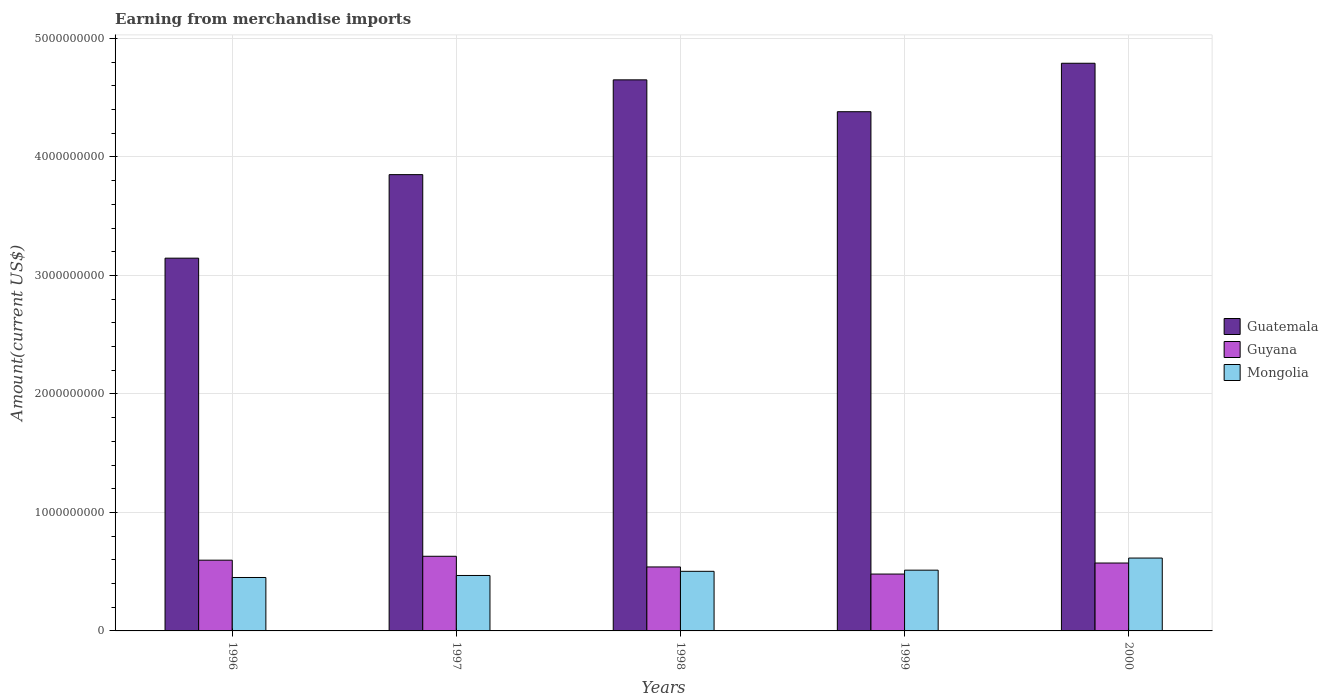How many groups of bars are there?
Give a very brief answer. 5. Are the number of bars per tick equal to the number of legend labels?
Give a very brief answer. Yes. Are the number of bars on each tick of the X-axis equal?
Offer a terse response. Yes. What is the amount earned from merchandise imports in Guyana in 1997?
Give a very brief answer. 6.30e+08. Across all years, what is the maximum amount earned from merchandise imports in Guyana?
Give a very brief answer. 6.30e+08. Across all years, what is the minimum amount earned from merchandise imports in Mongolia?
Give a very brief answer. 4.51e+08. In which year was the amount earned from merchandise imports in Guatemala maximum?
Offer a very short reply. 2000. What is the total amount earned from merchandise imports in Mongolia in the graph?
Ensure brevity in your answer.  2.55e+09. What is the difference between the amount earned from merchandise imports in Mongolia in 1996 and that in 1999?
Your answer should be compact. -6.18e+07. What is the difference between the amount earned from merchandise imports in Guyana in 2000 and the amount earned from merchandise imports in Mongolia in 1998?
Your answer should be very brief. 7.00e+07. What is the average amount earned from merchandise imports in Mongolia per year?
Your answer should be compact. 5.10e+08. In the year 1998, what is the difference between the amount earned from merchandise imports in Mongolia and amount earned from merchandise imports in Guyana?
Offer a very short reply. -3.70e+07. What is the ratio of the amount earned from merchandise imports in Guyana in 1996 to that in 1999?
Your answer should be compact. 1.24. Is the difference between the amount earned from merchandise imports in Mongolia in 1998 and 2000 greater than the difference between the amount earned from merchandise imports in Guyana in 1998 and 2000?
Offer a terse response. No. What is the difference between the highest and the second highest amount earned from merchandise imports in Guatemala?
Offer a very short reply. 1.40e+08. What is the difference between the highest and the lowest amount earned from merchandise imports in Guatemala?
Your answer should be compact. 1.64e+09. Is the sum of the amount earned from merchandise imports in Guatemala in 1996 and 1999 greater than the maximum amount earned from merchandise imports in Guyana across all years?
Make the answer very short. Yes. What does the 1st bar from the left in 2000 represents?
Make the answer very short. Guatemala. What does the 1st bar from the right in 1998 represents?
Make the answer very short. Mongolia. Are all the bars in the graph horizontal?
Provide a succinct answer. No. What is the difference between two consecutive major ticks on the Y-axis?
Your answer should be compact. 1.00e+09. Does the graph contain any zero values?
Offer a terse response. No. Does the graph contain grids?
Make the answer very short. Yes. How are the legend labels stacked?
Offer a very short reply. Vertical. What is the title of the graph?
Give a very brief answer. Earning from merchandise imports. Does "New Zealand" appear as one of the legend labels in the graph?
Give a very brief answer. No. What is the label or title of the Y-axis?
Make the answer very short. Amount(current US$). What is the Amount(current US$) in Guatemala in 1996?
Your response must be concise. 3.15e+09. What is the Amount(current US$) of Guyana in 1996?
Your answer should be very brief. 5.97e+08. What is the Amount(current US$) of Mongolia in 1996?
Give a very brief answer. 4.51e+08. What is the Amount(current US$) in Guatemala in 1997?
Keep it short and to the point. 3.85e+09. What is the Amount(current US$) in Guyana in 1997?
Provide a short and direct response. 6.30e+08. What is the Amount(current US$) of Mongolia in 1997?
Your answer should be compact. 4.68e+08. What is the Amount(current US$) of Guatemala in 1998?
Make the answer very short. 4.65e+09. What is the Amount(current US$) in Guyana in 1998?
Make the answer very short. 5.40e+08. What is the Amount(current US$) in Mongolia in 1998?
Your answer should be very brief. 5.03e+08. What is the Amount(current US$) in Guatemala in 1999?
Offer a terse response. 4.38e+09. What is the Amount(current US$) in Guyana in 1999?
Give a very brief answer. 4.80e+08. What is the Amount(current US$) of Mongolia in 1999?
Your response must be concise. 5.13e+08. What is the Amount(current US$) in Guatemala in 2000?
Your answer should be compact. 4.79e+09. What is the Amount(current US$) in Guyana in 2000?
Keep it short and to the point. 5.73e+08. What is the Amount(current US$) of Mongolia in 2000?
Keep it short and to the point. 6.15e+08. Across all years, what is the maximum Amount(current US$) of Guatemala?
Offer a terse response. 4.79e+09. Across all years, what is the maximum Amount(current US$) of Guyana?
Your answer should be compact. 6.30e+08. Across all years, what is the maximum Amount(current US$) in Mongolia?
Ensure brevity in your answer.  6.15e+08. Across all years, what is the minimum Amount(current US$) in Guatemala?
Provide a short and direct response. 3.15e+09. Across all years, what is the minimum Amount(current US$) of Guyana?
Ensure brevity in your answer.  4.80e+08. Across all years, what is the minimum Amount(current US$) in Mongolia?
Your response must be concise. 4.51e+08. What is the total Amount(current US$) of Guatemala in the graph?
Make the answer very short. 2.08e+1. What is the total Amount(current US$) in Guyana in the graph?
Give a very brief answer. 2.82e+09. What is the total Amount(current US$) in Mongolia in the graph?
Offer a terse response. 2.55e+09. What is the difference between the Amount(current US$) in Guatemala in 1996 and that in 1997?
Ensure brevity in your answer.  -7.05e+08. What is the difference between the Amount(current US$) in Guyana in 1996 and that in 1997?
Offer a very short reply. -3.30e+07. What is the difference between the Amount(current US$) of Mongolia in 1996 and that in 1997?
Your response must be concise. -1.70e+07. What is the difference between the Amount(current US$) of Guatemala in 1996 and that in 1998?
Provide a short and direct response. -1.50e+09. What is the difference between the Amount(current US$) in Guyana in 1996 and that in 1998?
Make the answer very short. 5.70e+07. What is the difference between the Amount(current US$) in Mongolia in 1996 and that in 1998?
Offer a terse response. -5.20e+07. What is the difference between the Amount(current US$) of Guatemala in 1996 and that in 1999?
Provide a succinct answer. -1.24e+09. What is the difference between the Amount(current US$) in Guyana in 1996 and that in 1999?
Make the answer very short. 1.17e+08. What is the difference between the Amount(current US$) in Mongolia in 1996 and that in 1999?
Provide a short and direct response. -6.18e+07. What is the difference between the Amount(current US$) in Guatemala in 1996 and that in 2000?
Provide a succinct answer. -1.64e+09. What is the difference between the Amount(current US$) of Guyana in 1996 and that in 2000?
Ensure brevity in your answer.  2.40e+07. What is the difference between the Amount(current US$) in Mongolia in 1996 and that in 2000?
Provide a short and direct response. -1.64e+08. What is the difference between the Amount(current US$) in Guatemala in 1997 and that in 1998?
Provide a succinct answer. -8.00e+08. What is the difference between the Amount(current US$) of Guyana in 1997 and that in 1998?
Keep it short and to the point. 9.00e+07. What is the difference between the Amount(current US$) of Mongolia in 1997 and that in 1998?
Make the answer very short. -3.50e+07. What is the difference between the Amount(current US$) of Guatemala in 1997 and that in 1999?
Ensure brevity in your answer.  -5.31e+08. What is the difference between the Amount(current US$) of Guyana in 1997 and that in 1999?
Give a very brief answer. 1.50e+08. What is the difference between the Amount(current US$) in Mongolia in 1997 and that in 1999?
Offer a very short reply. -4.48e+07. What is the difference between the Amount(current US$) of Guatemala in 1997 and that in 2000?
Provide a succinct answer. -9.40e+08. What is the difference between the Amount(current US$) of Guyana in 1997 and that in 2000?
Offer a very short reply. 5.70e+07. What is the difference between the Amount(current US$) in Mongolia in 1997 and that in 2000?
Your response must be concise. -1.47e+08. What is the difference between the Amount(current US$) of Guatemala in 1998 and that in 1999?
Provide a succinct answer. 2.69e+08. What is the difference between the Amount(current US$) in Guyana in 1998 and that in 1999?
Make the answer very short. 6.00e+07. What is the difference between the Amount(current US$) of Mongolia in 1998 and that in 1999?
Keep it short and to the point. -9.80e+06. What is the difference between the Amount(current US$) in Guatemala in 1998 and that in 2000?
Your answer should be compact. -1.40e+08. What is the difference between the Amount(current US$) in Guyana in 1998 and that in 2000?
Offer a very short reply. -3.30e+07. What is the difference between the Amount(current US$) of Mongolia in 1998 and that in 2000?
Provide a short and direct response. -1.12e+08. What is the difference between the Amount(current US$) in Guatemala in 1999 and that in 2000?
Offer a terse response. -4.09e+08. What is the difference between the Amount(current US$) in Guyana in 1999 and that in 2000?
Offer a terse response. -9.30e+07. What is the difference between the Amount(current US$) in Mongolia in 1999 and that in 2000?
Your answer should be compact. -1.02e+08. What is the difference between the Amount(current US$) in Guatemala in 1996 and the Amount(current US$) in Guyana in 1997?
Provide a short and direct response. 2.52e+09. What is the difference between the Amount(current US$) in Guatemala in 1996 and the Amount(current US$) in Mongolia in 1997?
Ensure brevity in your answer.  2.68e+09. What is the difference between the Amount(current US$) of Guyana in 1996 and the Amount(current US$) of Mongolia in 1997?
Offer a very short reply. 1.29e+08. What is the difference between the Amount(current US$) of Guatemala in 1996 and the Amount(current US$) of Guyana in 1998?
Offer a very short reply. 2.61e+09. What is the difference between the Amount(current US$) in Guatemala in 1996 and the Amount(current US$) in Mongolia in 1998?
Offer a very short reply. 2.64e+09. What is the difference between the Amount(current US$) of Guyana in 1996 and the Amount(current US$) of Mongolia in 1998?
Ensure brevity in your answer.  9.40e+07. What is the difference between the Amount(current US$) in Guatemala in 1996 and the Amount(current US$) in Guyana in 1999?
Ensure brevity in your answer.  2.67e+09. What is the difference between the Amount(current US$) in Guatemala in 1996 and the Amount(current US$) in Mongolia in 1999?
Your answer should be very brief. 2.63e+09. What is the difference between the Amount(current US$) of Guyana in 1996 and the Amount(current US$) of Mongolia in 1999?
Offer a very short reply. 8.42e+07. What is the difference between the Amount(current US$) in Guatemala in 1996 and the Amount(current US$) in Guyana in 2000?
Provide a succinct answer. 2.57e+09. What is the difference between the Amount(current US$) in Guatemala in 1996 and the Amount(current US$) in Mongolia in 2000?
Make the answer very short. 2.53e+09. What is the difference between the Amount(current US$) in Guyana in 1996 and the Amount(current US$) in Mongolia in 2000?
Ensure brevity in your answer.  -1.80e+07. What is the difference between the Amount(current US$) of Guatemala in 1997 and the Amount(current US$) of Guyana in 1998?
Your answer should be compact. 3.31e+09. What is the difference between the Amount(current US$) in Guatemala in 1997 and the Amount(current US$) in Mongolia in 1998?
Provide a succinct answer. 3.35e+09. What is the difference between the Amount(current US$) in Guyana in 1997 and the Amount(current US$) in Mongolia in 1998?
Make the answer very short. 1.27e+08. What is the difference between the Amount(current US$) of Guatemala in 1997 and the Amount(current US$) of Guyana in 1999?
Provide a short and direct response. 3.37e+09. What is the difference between the Amount(current US$) of Guatemala in 1997 and the Amount(current US$) of Mongolia in 1999?
Ensure brevity in your answer.  3.34e+09. What is the difference between the Amount(current US$) in Guyana in 1997 and the Amount(current US$) in Mongolia in 1999?
Your answer should be compact. 1.17e+08. What is the difference between the Amount(current US$) of Guatemala in 1997 and the Amount(current US$) of Guyana in 2000?
Make the answer very short. 3.28e+09. What is the difference between the Amount(current US$) in Guatemala in 1997 and the Amount(current US$) in Mongolia in 2000?
Keep it short and to the point. 3.24e+09. What is the difference between the Amount(current US$) in Guyana in 1997 and the Amount(current US$) in Mongolia in 2000?
Ensure brevity in your answer.  1.50e+07. What is the difference between the Amount(current US$) in Guatemala in 1998 and the Amount(current US$) in Guyana in 1999?
Ensure brevity in your answer.  4.17e+09. What is the difference between the Amount(current US$) in Guatemala in 1998 and the Amount(current US$) in Mongolia in 1999?
Your answer should be compact. 4.14e+09. What is the difference between the Amount(current US$) of Guyana in 1998 and the Amount(current US$) of Mongolia in 1999?
Make the answer very short. 2.72e+07. What is the difference between the Amount(current US$) of Guatemala in 1998 and the Amount(current US$) of Guyana in 2000?
Your response must be concise. 4.08e+09. What is the difference between the Amount(current US$) in Guatemala in 1998 and the Amount(current US$) in Mongolia in 2000?
Ensure brevity in your answer.  4.04e+09. What is the difference between the Amount(current US$) of Guyana in 1998 and the Amount(current US$) of Mongolia in 2000?
Your answer should be very brief. -7.50e+07. What is the difference between the Amount(current US$) of Guatemala in 1999 and the Amount(current US$) of Guyana in 2000?
Provide a succinct answer. 3.81e+09. What is the difference between the Amount(current US$) of Guatemala in 1999 and the Amount(current US$) of Mongolia in 2000?
Offer a terse response. 3.77e+09. What is the difference between the Amount(current US$) of Guyana in 1999 and the Amount(current US$) of Mongolia in 2000?
Offer a terse response. -1.35e+08. What is the average Amount(current US$) of Guatemala per year?
Make the answer very short. 4.16e+09. What is the average Amount(current US$) of Guyana per year?
Provide a short and direct response. 5.64e+08. What is the average Amount(current US$) in Mongolia per year?
Your response must be concise. 5.10e+08. In the year 1996, what is the difference between the Amount(current US$) of Guatemala and Amount(current US$) of Guyana?
Your response must be concise. 2.55e+09. In the year 1996, what is the difference between the Amount(current US$) in Guatemala and Amount(current US$) in Mongolia?
Make the answer very short. 2.70e+09. In the year 1996, what is the difference between the Amount(current US$) of Guyana and Amount(current US$) of Mongolia?
Your response must be concise. 1.46e+08. In the year 1997, what is the difference between the Amount(current US$) of Guatemala and Amount(current US$) of Guyana?
Provide a short and direct response. 3.22e+09. In the year 1997, what is the difference between the Amount(current US$) in Guatemala and Amount(current US$) in Mongolia?
Keep it short and to the point. 3.38e+09. In the year 1997, what is the difference between the Amount(current US$) in Guyana and Amount(current US$) in Mongolia?
Your answer should be compact. 1.62e+08. In the year 1998, what is the difference between the Amount(current US$) in Guatemala and Amount(current US$) in Guyana?
Offer a terse response. 4.11e+09. In the year 1998, what is the difference between the Amount(current US$) of Guatemala and Amount(current US$) of Mongolia?
Your answer should be compact. 4.15e+09. In the year 1998, what is the difference between the Amount(current US$) of Guyana and Amount(current US$) of Mongolia?
Your answer should be very brief. 3.70e+07. In the year 1999, what is the difference between the Amount(current US$) of Guatemala and Amount(current US$) of Guyana?
Your answer should be very brief. 3.90e+09. In the year 1999, what is the difference between the Amount(current US$) in Guatemala and Amount(current US$) in Mongolia?
Provide a short and direct response. 3.87e+09. In the year 1999, what is the difference between the Amount(current US$) of Guyana and Amount(current US$) of Mongolia?
Your answer should be compact. -3.28e+07. In the year 2000, what is the difference between the Amount(current US$) of Guatemala and Amount(current US$) of Guyana?
Your answer should be very brief. 4.22e+09. In the year 2000, what is the difference between the Amount(current US$) in Guatemala and Amount(current US$) in Mongolia?
Your response must be concise. 4.18e+09. In the year 2000, what is the difference between the Amount(current US$) in Guyana and Amount(current US$) in Mongolia?
Offer a terse response. -4.20e+07. What is the ratio of the Amount(current US$) in Guatemala in 1996 to that in 1997?
Offer a terse response. 0.82. What is the ratio of the Amount(current US$) of Guyana in 1996 to that in 1997?
Ensure brevity in your answer.  0.95. What is the ratio of the Amount(current US$) in Mongolia in 1996 to that in 1997?
Offer a terse response. 0.96. What is the ratio of the Amount(current US$) in Guatemala in 1996 to that in 1998?
Offer a very short reply. 0.68. What is the ratio of the Amount(current US$) in Guyana in 1996 to that in 1998?
Your response must be concise. 1.11. What is the ratio of the Amount(current US$) of Mongolia in 1996 to that in 1998?
Ensure brevity in your answer.  0.9. What is the ratio of the Amount(current US$) of Guatemala in 1996 to that in 1999?
Provide a succinct answer. 0.72. What is the ratio of the Amount(current US$) in Guyana in 1996 to that in 1999?
Offer a very short reply. 1.24. What is the ratio of the Amount(current US$) in Mongolia in 1996 to that in 1999?
Offer a terse response. 0.88. What is the ratio of the Amount(current US$) of Guatemala in 1996 to that in 2000?
Offer a terse response. 0.66. What is the ratio of the Amount(current US$) of Guyana in 1996 to that in 2000?
Your answer should be very brief. 1.04. What is the ratio of the Amount(current US$) in Mongolia in 1996 to that in 2000?
Your answer should be very brief. 0.73. What is the ratio of the Amount(current US$) in Guatemala in 1997 to that in 1998?
Offer a terse response. 0.83. What is the ratio of the Amount(current US$) of Guyana in 1997 to that in 1998?
Provide a succinct answer. 1.17. What is the ratio of the Amount(current US$) of Mongolia in 1997 to that in 1998?
Give a very brief answer. 0.93. What is the ratio of the Amount(current US$) in Guatemala in 1997 to that in 1999?
Give a very brief answer. 0.88. What is the ratio of the Amount(current US$) of Guyana in 1997 to that in 1999?
Make the answer very short. 1.31. What is the ratio of the Amount(current US$) of Mongolia in 1997 to that in 1999?
Your answer should be very brief. 0.91. What is the ratio of the Amount(current US$) in Guatemala in 1997 to that in 2000?
Make the answer very short. 0.8. What is the ratio of the Amount(current US$) of Guyana in 1997 to that in 2000?
Offer a terse response. 1.1. What is the ratio of the Amount(current US$) in Mongolia in 1997 to that in 2000?
Ensure brevity in your answer.  0.76. What is the ratio of the Amount(current US$) in Guatemala in 1998 to that in 1999?
Provide a short and direct response. 1.06. What is the ratio of the Amount(current US$) of Mongolia in 1998 to that in 1999?
Offer a terse response. 0.98. What is the ratio of the Amount(current US$) of Guatemala in 1998 to that in 2000?
Provide a succinct answer. 0.97. What is the ratio of the Amount(current US$) in Guyana in 1998 to that in 2000?
Give a very brief answer. 0.94. What is the ratio of the Amount(current US$) of Mongolia in 1998 to that in 2000?
Make the answer very short. 0.82. What is the ratio of the Amount(current US$) in Guatemala in 1999 to that in 2000?
Your answer should be very brief. 0.91. What is the ratio of the Amount(current US$) of Guyana in 1999 to that in 2000?
Offer a terse response. 0.84. What is the ratio of the Amount(current US$) of Mongolia in 1999 to that in 2000?
Offer a terse response. 0.83. What is the difference between the highest and the second highest Amount(current US$) in Guatemala?
Offer a terse response. 1.40e+08. What is the difference between the highest and the second highest Amount(current US$) in Guyana?
Provide a short and direct response. 3.30e+07. What is the difference between the highest and the second highest Amount(current US$) of Mongolia?
Your answer should be very brief. 1.02e+08. What is the difference between the highest and the lowest Amount(current US$) in Guatemala?
Offer a very short reply. 1.64e+09. What is the difference between the highest and the lowest Amount(current US$) in Guyana?
Ensure brevity in your answer.  1.50e+08. What is the difference between the highest and the lowest Amount(current US$) of Mongolia?
Your answer should be very brief. 1.64e+08. 